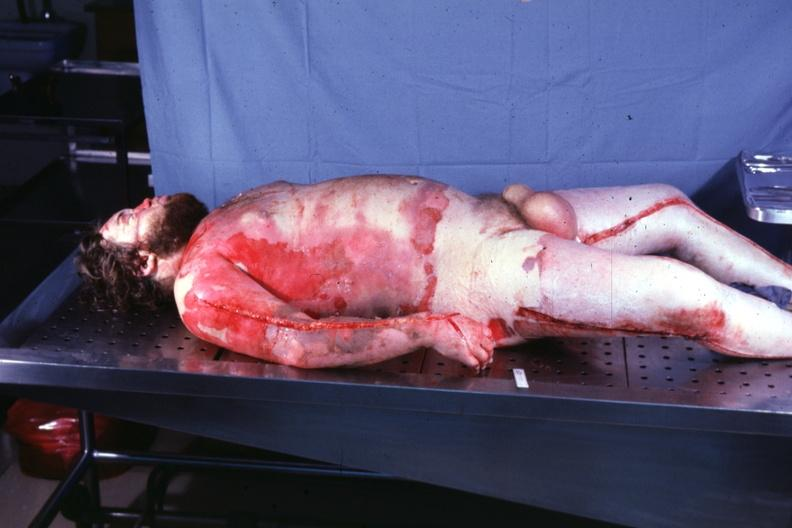what does this image show?
Answer the question using a single word or phrase. Body burns 24 hours prior now anasarca 